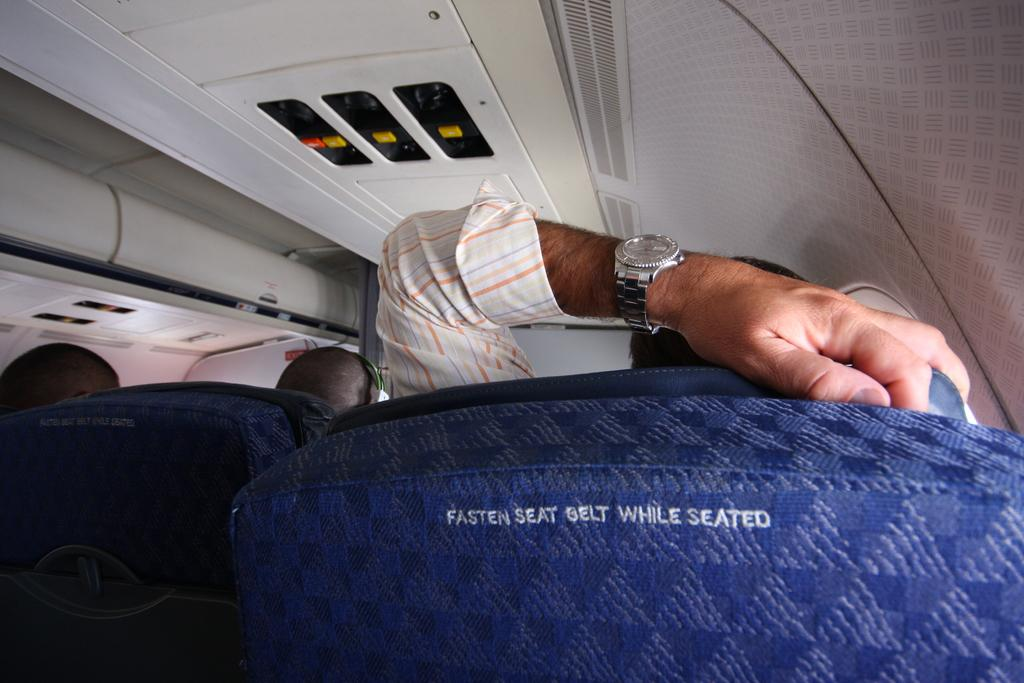<image>
Create a compact narrative representing the image presented. A man's arm with a wrist watch resting on a blue seat on an airplane with the words fasten seat belt while seated across the back. 